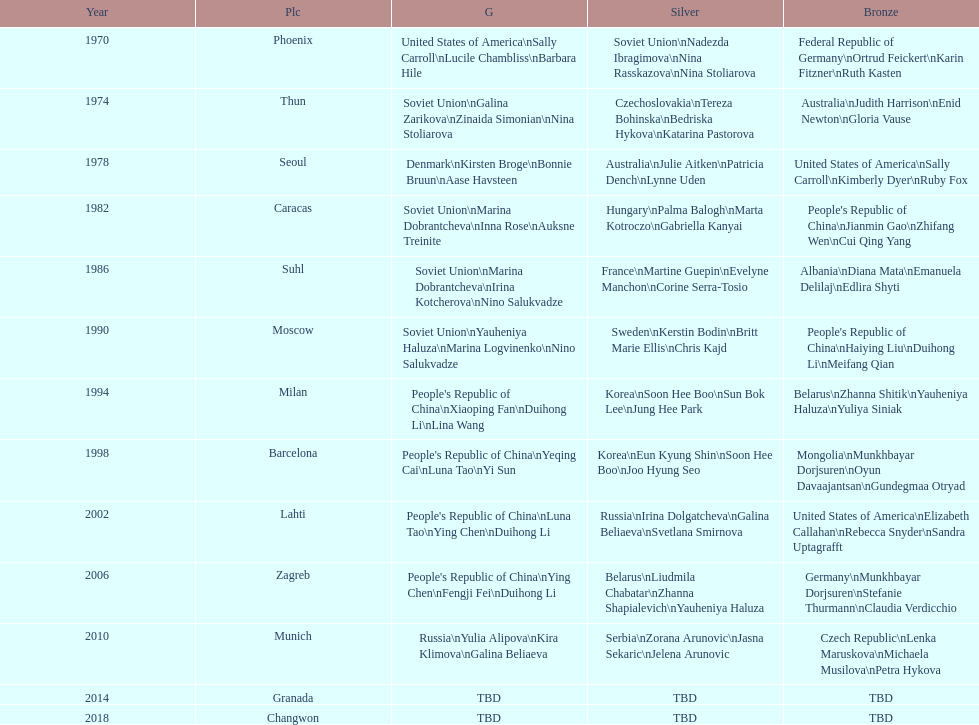Parse the table in full. {'header': ['Year', 'Plc', 'G', 'Silver', 'Bronze'], 'rows': [['1970', 'Phoenix', 'United States of America\\nSally Carroll\\nLucile Chambliss\\nBarbara Hile', 'Soviet Union\\nNadezda Ibragimova\\nNina Rasskazova\\nNina Stoliarova', 'Federal Republic of Germany\\nOrtrud Feickert\\nKarin Fitzner\\nRuth Kasten'], ['1974', 'Thun', 'Soviet Union\\nGalina Zarikova\\nZinaida Simonian\\nNina Stoliarova', 'Czechoslovakia\\nTereza Bohinska\\nBedriska Hykova\\nKatarina Pastorova', 'Australia\\nJudith Harrison\\nEnid Newton\\nGloria Vause'], ['1978', 'Seoul', 'Denmark\\nKirsten Broge\\nBonnie Bruun\\nAase Havsteen', 'Australia\\nJulie Aitken\\nPatricia Dench\\nLynne Uden', 'United States of America\\nSally Carroll\\nKimberly Dyer\\nRuby Fox'], ['1982', 'Caracas', 'Soviet Union\\nMarina Dobrantcheva\\nInna Rose\\nAuksne Treinite', 'Hungary\\nPalma Balogh\\nMarta Kotroczo\\nGabriella Kanyai', "People's Republic of China\\nJianmin Gao\\nZhifang Wen\\nCui Qing Yang"], ['1986', 'Suhl', 'Soviet Union\\nMarina Dobrantcheva\\nIrina Kotcherova\\nNino Salukvadze', 'France\\nMartine Guepin\\nEvelyne Manchon\\nCorine Serra-Tosio', 'Albania\\nDiana Mata\\nEmanuela Delilaj\\nEdlira Shyti'], ['1990', 'Moscow', 'Soviet Union\\nYauheniya Haluza\\nMarina Logvinenko\\nNino Salukvadze', 'Sweden\\nKerstin Bodin\\nBritt Marie Ellis\\nChris Kajd', "People's Republic of China\\nHaiying Liu\\nDuihong Li\\nMeifang Qian"], ['1994', 'Milan', "People's Republic of China\\nXiaoping Fan\\nDuihong Li\\nLina Wang", 'Korea\\nSoon Hee Boo\\nSun Bok Lee\\nJung Hee Park', 'Belarus\\nZhanna Shitik\\nYauheniya Haluza\\nYuliya Siniak'], ['1998', 'Barcelona', "People's Republic of China\\nYeqing Cai\\nLuna Tao\\nYi Sun", 'Korea\\nEun Kyung Shin\\nSoon Hee Boo\\nJoo Hyung Seo', 'Mongolia\\nMunkhbayar Dorjsuren\\nOyun Davaajantsan\\nGundegmaa Otryad'], ['2002', 'Lahti', "People's Republic of China\\nLuna Tao\\nYing Chen\\nDuihong Li", 'Russia\\nIrina Dolgatcheva\\nGalina Beliaeva\\nSvetlana Smirnova', 'United States of America\\nElizabeth Callahan\\nRebecca Snyder\\nSandra Uptagrafft'], ['2006', 'Zagreb', "People's Republic of China\\nYing Chen\\nFengji Fei\\nDuihong Li", 'Belarus\\nLiudmila Chabatar\\nZhanna Shapialevich\\nYauheniya Haluza', 'Germany\\nMunkhbayar Dorjsuren\\nStefanie Thurmann\\nClaudia Verdicchio'], ['2010', 'Munich', 'Russia\\nYulia Alipova\\nKira Klimova\\nGalina Beliaeva', 'Serbia\\nZorana Arunovic\\nJasna Sekaric\\nJelena Arunovic', 'Czech Republic\\nLenka Maruskova\\nMichaela Musilova\\nPetra Hykova'], ['2014', 'Granada', 'TBD', 'TBD', 'TBD'], ['2018', 'Changwon', 'TBD', 'TBD', 'TBD']]} Which country is listed the most under the silver column? Korea. 